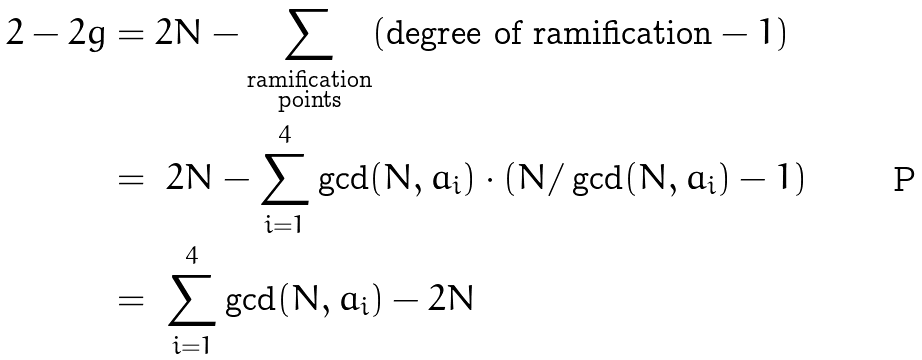<formula> <loc_0><loc_0><loc_500><loc_500>2 - 2 g & = 2 N - \sum _ { \substack { \text {ramification} \\ \text {points} } } ( \text {degree of ramification} - 1 ) \\ & = \ 2 N - \sum _ { i = 1 } ^ { 4 } \gcd ( N , a _ { i } ) \cdot \left ( N / \gcd ( N , a _ { i } ) - 1 \right ) \\ & = \ \sum _ { i = 1 } ^ { 4 } \gcd ( N , a _ { i } ) - 2 N</formula> 